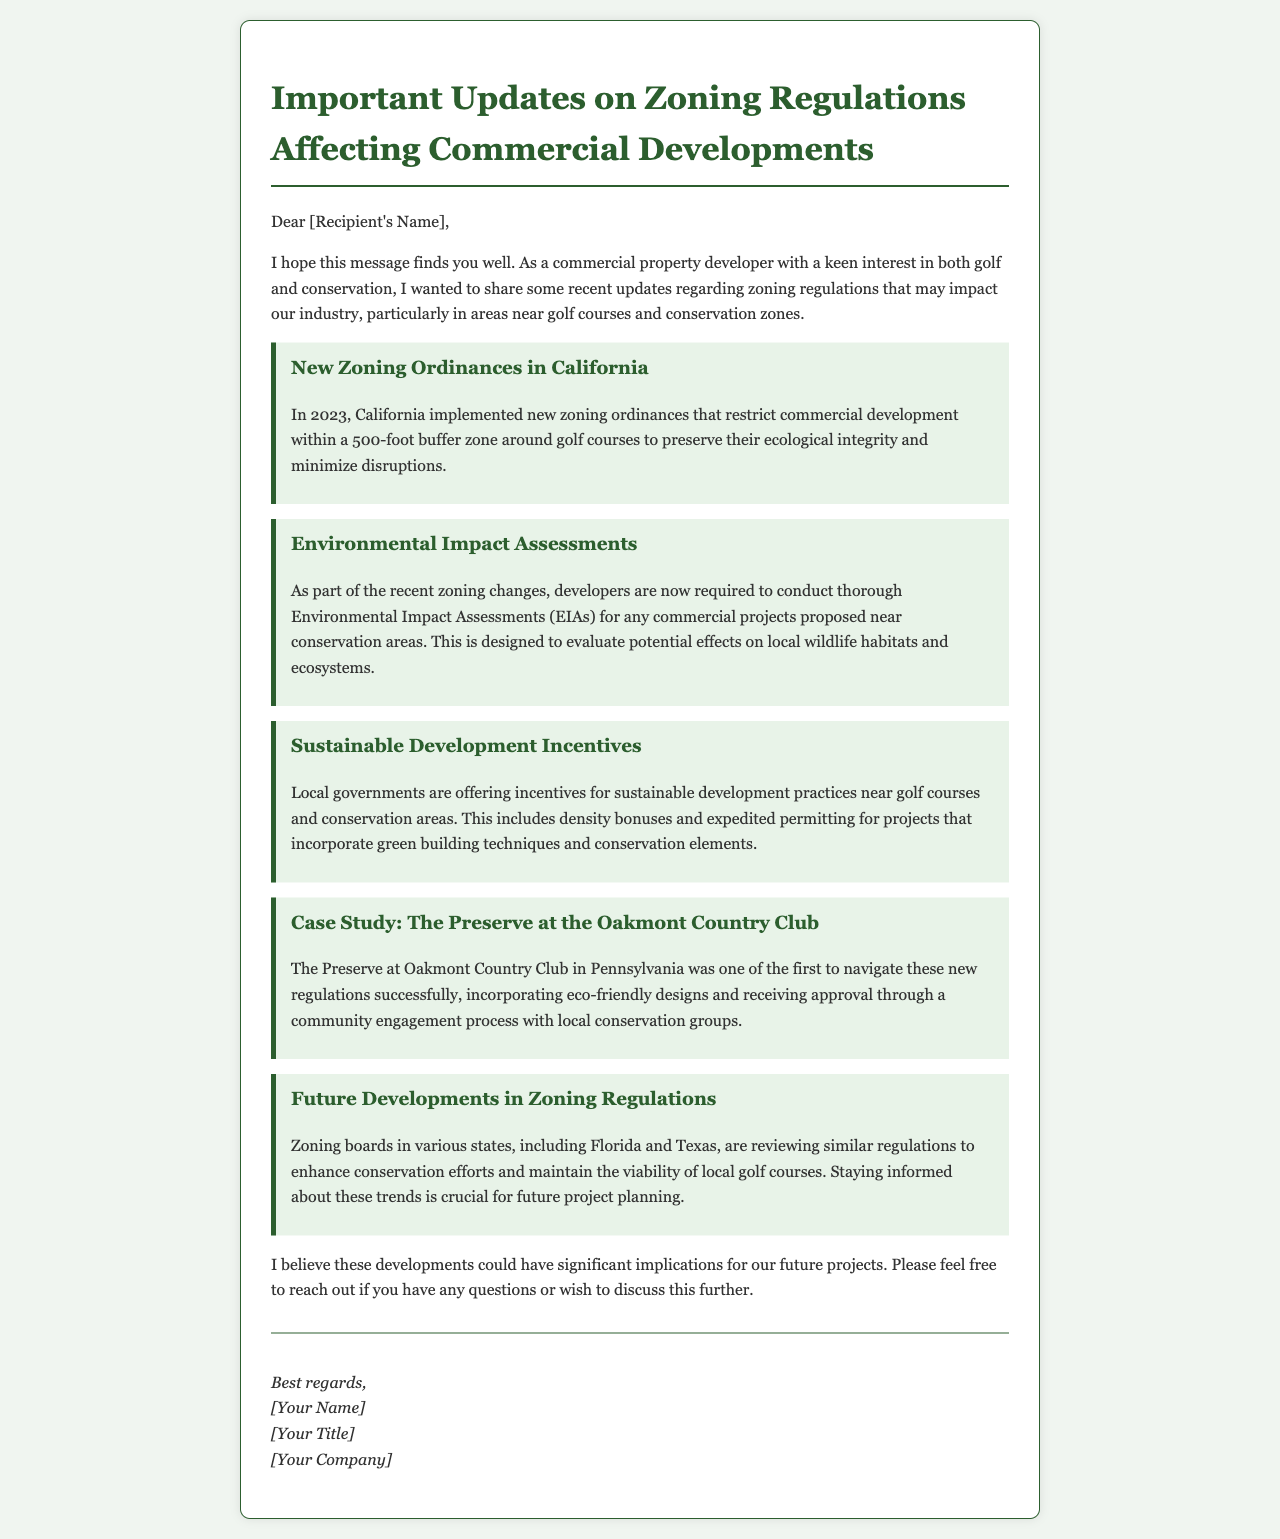What year were the new zoning ordinances implemented in California? The document states that the new zoning ordinances were implemented in the year 2023.
Answer: 2023 What is the required buffer zone around golf courses according to the new regulations? The new regulations state that there is a 500-foot buffer zone around golf courses to preserve their ecological integrity.
Answer: 500-foot What are developers now required to conduct near conservation areas? The document mentions that developers are required to conduct thorough Environmental Impact Assessments (EIAs) for projects near conservation areas.
Answer: Environmental Impact Assessments (EIAs) What kind of incentives are local governments offering? Local governments are offering incentives for sustainable development practices, including density bonuses and expedited permitting.
Answer: Sustainable development practices Which country club is mentioned as a case study in the document? The case study referenced in the document is "The Preserve at Oakmont Country Club."
Answer: The Preserve at Oakmont Country Club What are zoning boards in Florida and Texas reviewing? The document indicates that zoning boards in Florida and Texas are reviewing regulations to enhance conservation efforts.
Answer: Regulations to enhance conservation efforts Who is the sender of the email? The sender's name is left as a placeholder in the document, stating "[Your Name]."
Answer: [Your Name] What is the main subject of the email? The main subject of the email is an update regarding zoning regulations impacting commercial developments.
Answer: Zoning regulations impacting commercial developments 